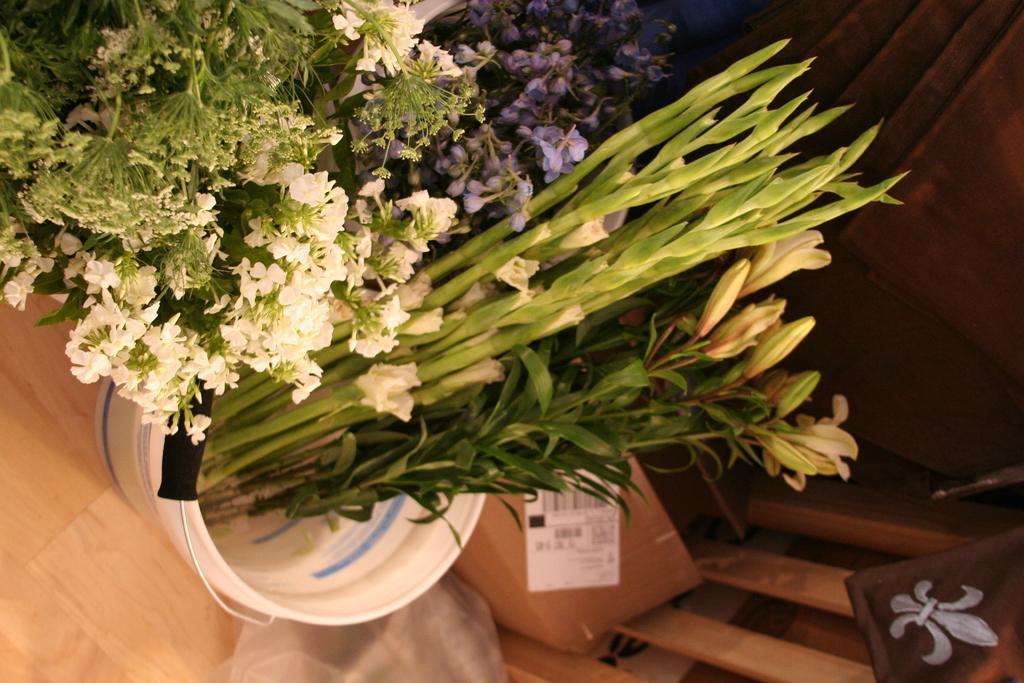In one or two sentences, can you explain what this image depicts? In this image I can see some plants. I can see the flowers. In the background, I can see a door. 